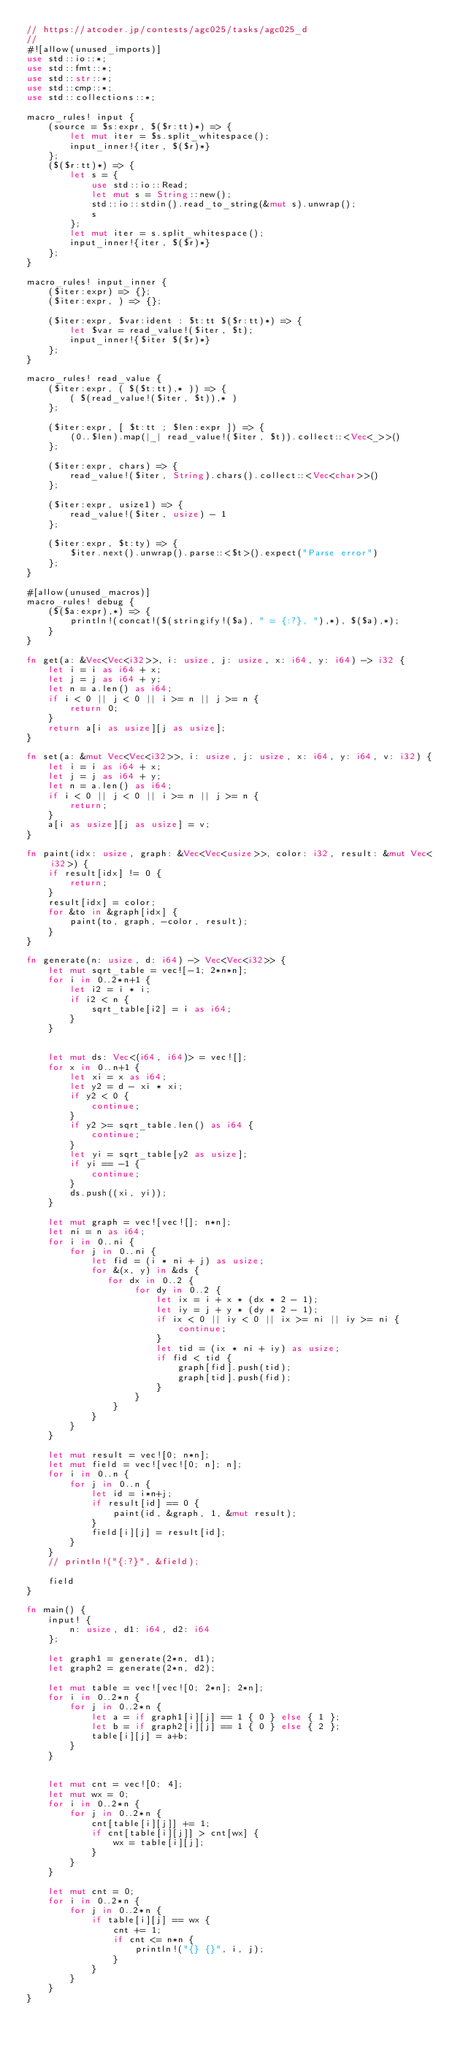<code> <loc_0><loc_0><loc_500><loc_500><_Rust_>// https://atcoder.jp/contests/agc025/tasks/agc025_d
//
#![allow(unused_imports)]
use std::io::*;
use std::fmt::*;
use std::str::*;
use std::cmp::*;
use std::collections::*;

macro_rules! input {
    (source = $s:expr, $($r:tt)*) => {
        let mut iter = $s.split_whitespace();
        input_inner!{iter, $($r)*}
    };
    ($($r:tt)*) => {
        let s = {
            use std::io::Read;
            let mut s = String::new();
            std::io::stdin().read_to_string(&mut s).unwrap();
            s
        };
        let mut iter = s.split_whitespace();
        input_inner!{iter, $($r)*}
    };
}

macro_rules! input_inner {
    ($iter:expr) => {};
    ($iter:expr, ) => {};

    ($iter:expr, $var:ident : $t:tt $($r:tt)*) => {
        let $var = read_value!($iter, $t);
        input_inner!{$iter $($r)*}
    };
}

macro_rules! read_value {
    ($iter:expr, ( $($t:tt),* )) => {
        ( $(read_value!($iter, $t)),* )
    };

    ($iter:expr, [ $t:tt ; $len:expr ]) => {
        (0..$len).map(|_| read_value!($iter, $t)).collect::<Vec<_>>()
    };

    ($iter:expr, chars) => {
        read_value!($iter, String).chars().collect::<Vec<char>>()
    };

    ($iter:expr, usize1) => {
        read_value!($iter, usize) - 1
    };

    ($iter:expr, $t:ty) => {
        $iter.next().unwrap().parse::<$t>().expect("Parse error")
    };
}

#[allow(unused_macros)]
macro_rules! debug {
    ($($a:expr),*) => {
        println!(concat!($(stringify!($a), " = {:?}, "),*), $($a),*);
    }
}

fn get(a: &Vec<Vec<i32>>, i: usize, j: usize, x: i64, y: i64) -> i32 {
    let i = i as i64 + x;
    let j = j as i64 + y;
    let n = a.len() as i64;
    if i < 0 || j < 0 || i >= n || j >= n {
        return 0;
    }
    return a[i as usize][j as usize];
}

fn set(a: &mut Vec<Vec<i32>>, i: usize, j: usize, x: i64, y: i64, v: i32) {
    let i = i as i64 + x;
    let j = j as i64 + y;
    let n = a.len() as i64;
    if i < 0 || j < 0 || i >= n || j >= n {
        return;
    }
    a[i as usize][j as usize] = v;
}

fn paint(idx: usize, graph: &Vec<Vec<usize>>, color: i32, result: &mut Vec<i32>) {
    if result[idx] != 0 {
        return;
    }
    result[idx] = color;
    for &to in &graph[idx] {
        paint(to, graph, -color, result);
    }
}

fn generate(n: usize, d: i64) -> Vec<Vec<i32>> {
    let mut sqrt_table = vec![-1; 2*n*n];
    for i in 0..2*n+1 {
        let i2 = i * i;
        if i2 < n {
            sqrt_table[i2] = i as i64;
        }
    }


    let mut ds: Vec<(i64, i64)> = vec![];
    for x in 0..n+1 {
        let xi = x as i64;
        let y2 = d - xi * xi;
        if y2 < 0 {
            continue;
        }
        if y2 >= sqrt_table.len() as i64 {
            continue;
        }
        let yi = sqrt_table[y2 as usize];
        if yi == -1 {
            continue;
        }
        ds.push((xi, yi));
    }

    let mut graph = vec![vec![]; n*n];
    let ni = n as i64;
    for i in 0..ni {
        for j in 0..ni {
            let fid = (i * ni + j) as usize;
            for &(x, y) in &ds {
               for dx in 0..2 {
                    for dy in 0..2 {
                        let ix = i + x * (dx * 2 - 1);
                        let iy = j + y * (dy * 2 - 1);
                        if ix < 0 || iy < 0 || ix >= ni || iy >= ni {
                            continue;
                        }
                        let tid = (ix * ni + iy) as usize;
                        if fid < tid {
                            graph[fid].push(tid);
                            graph[tid].push(fid);
                        }
                    }
                }
            }
        }
    }

    let mut result = vec![0; n*n];
    let mut field = vec![vec![0; n]; n];
    for i in 0..n {
        for j in 0..n {
            let id = i*n+j;
            if result[id] == 0 {
                paint(id, &graph, 1, &mut result);
            }
            field[i][j] = result[id];
        }
    }
    // println!("{:?}", &field);

    field
}

fn main() {
    input! {
        n: usize, d1: i64, d2: i64
    };

    let graph1 = generate(2*n, d1);
    let graph2 = generate(2*n, d2);

    let mut table = vec![vec![0; 2*n]; 2*n];
    for i in 0..2*n {
        for j in 0..2*n {
            let a = if graph1[i][j] == 1 { 0 } else { 1 };
            let b = if graph2[i][j] == 1 { 0 } else { 2 };
            table[i][j] = a+b;
        }
    }


    let mut cnt = vec![0; 4];
    let mut wx = 0;
    for i in 0..2*n {
        for j in 0..2*n {
            cnt[table[i][j]] += 1;
            if cnt[table[i][j]] > cnt[wx] {
                wx = table[i][j];
            }
        }
    }

    let mut cnt = 0;
    for i in 0..2*n {
        for j in 0..2*n {
            if table[i][j] == wx {
                cnt += 1;
                if cnt <= n*n {
                    println!("{} {}", i, j);
                }
            }
        }
    }
}
</code> 